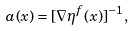<formula> <loc_0><loc_0><loc_500><loc_500>a ( x ) = [ \nabla \eta ^ { f } ( x ) ] ^ { - 1 } ,</formula> 